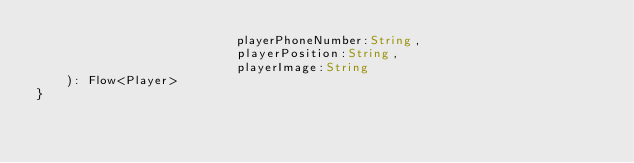<code> <loc_0><loc_0><loc_500><loc_500><_Kotlin_>                           playerPhoneNumber:String,
                           playerPosition:String,
                           playerImage:String
    ): Flow<Player>
}</code> 